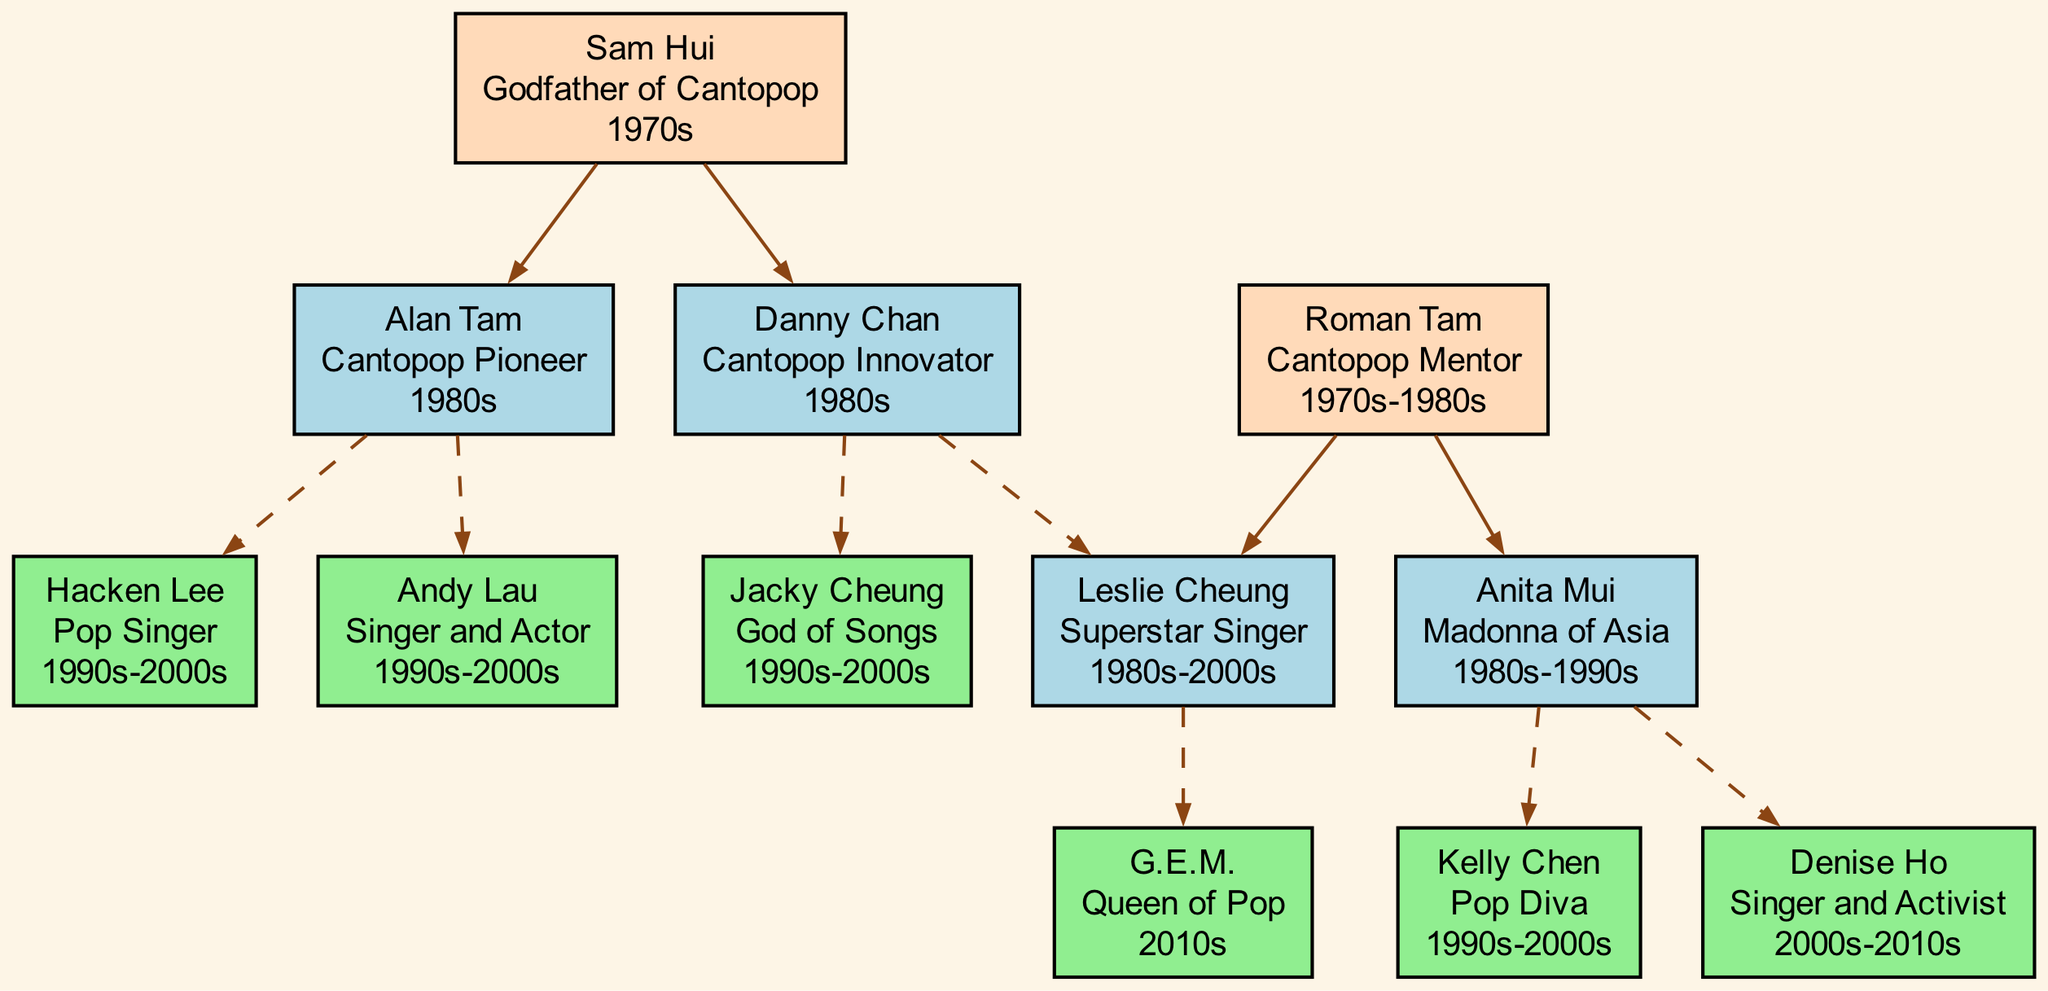What is the role of Sam Hui in the diagram? The diagram shows Sam Hui identified as the "Godfather of Cantopop". This information is present in the node that represents him.
Answer: Godfather of Cantopop Who are the mentees of Alan Tam? The diagram lists the mentees of Alan Tam, which are Hacken Lee and Andy Lau. They are connected to Alan Tam through dashed lines indicating the mentorship relationships.
Answer: Hacken Lee, Andy Lau How many nodes are there in the diagram? By counting the unique individuals and groups represented in the diagram, including both mentors and their mentees, we find there are 11 nodes total.
Answer: 11 Which artist has the title "Queen of Pop"? In the diagram, G.E.M. is labeled as the "Queen of Pop", which is directly stated in her node.
Answer: G.E.M Who was mentored by both Danny Chan and Roman Tam? The diagram shows Leslie Cheung connected to both Danny Chan as a mentee and Roman Tam as a child, indicating he has relationships with both mentors.
Answer: Leslie Cheung What era does Anita Mui belong to? The information in the diagram indicates that Anita Mui's era is 1980s-1990s, denoted in her node alongside her role "Madonna of Asia".
Answer: 1980s-1990s How many mentees does Roman Tam have? Upon examining Roman Tam's node in the diagram, we see he has two children (Anita Mui, Leslie Cheung), and Anita Mui has two mentees. Leslie Cheung has one mentee. Adding them gives a total of 4 mentees.
Answer: 4 Which artist is described as the "God of Songs"? The diagram clearly indicates Jacky Cheung’s title as the "God of Songs" in his respective node.
Answer: Jacky Cheung What relationship does Kelly Chen have with Anita Mui? The diagram depicts Kelly Chen as a mentee of Anita Mui, establishing a direct mentorship relationship between the two.
Answer: Mentees What role did Danny Chan play in the Cantopop scene? The diagram labels Danny Chan as a "Cantopop Innovator", which is prominently noted in his section of the family tree.
Answer: Cantopop Innovator 